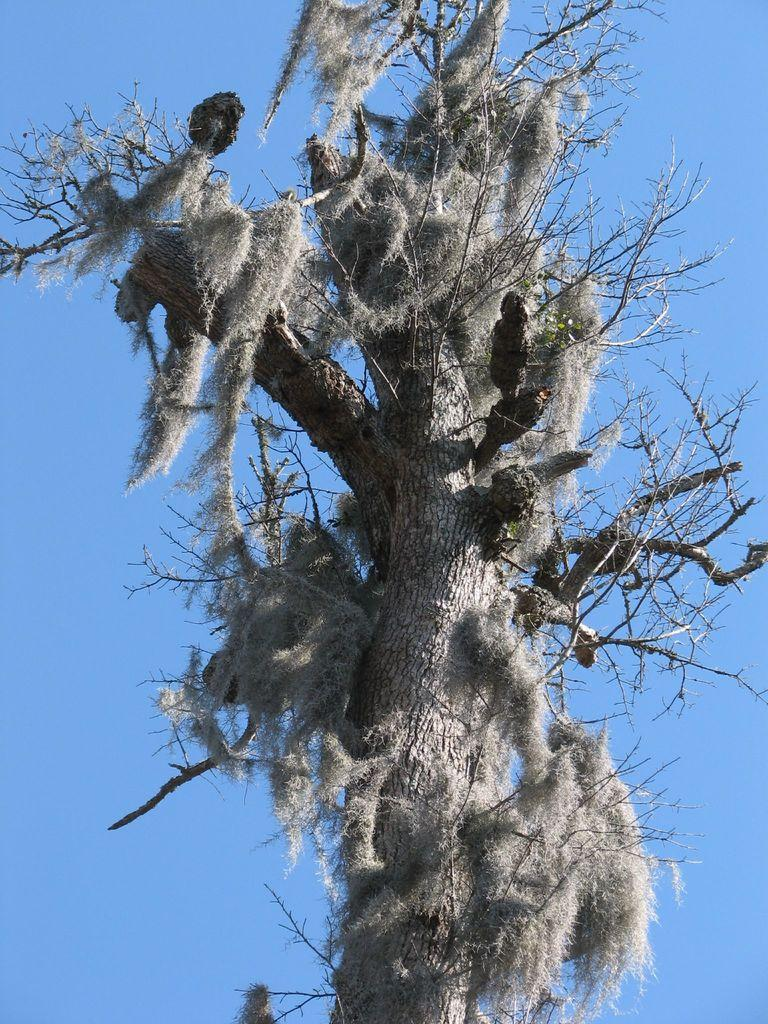What is the main subject in the center of the image? There is a tree in the center of the image. What can be seen in the background of the image? The sky is visible in the background of the image. What is the man's opinion about the tree in the image? There is no man present in the image, so it is not possible to determine his opinion about the tree. 